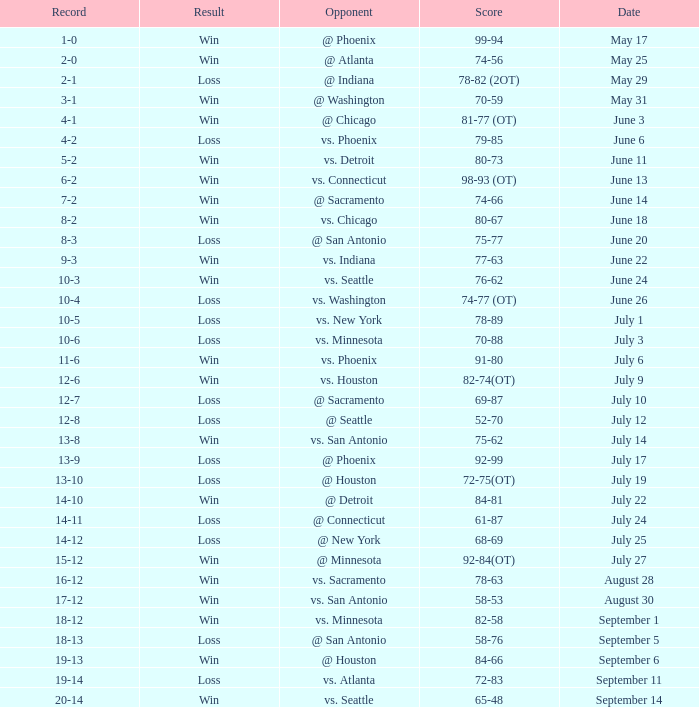What is the Score of the game @ San Antonio on June 20? 75-77. 